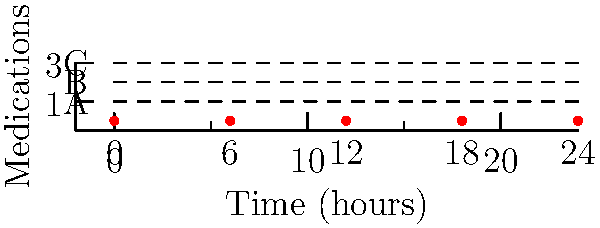As a heart patient, you're prescribed three medications (A, B, and C) to be taken at different times throughout the day. The diagram shows a 24-hour schedule grid. How many unique ways can you arrange these medications if each must be taken exactly once within the given time slots (0, 6, 12, 18, 24 hours), and the order of medications matters? Let's approach this step-by-step:

1) We have 5 time slots (0, 6, 12, 18, 24 hours) and 3 medications (A, B, C).

2) This is a permutation problem because the order matters (taking medication A at 0 hours is different from taking it at 6 hours).

3) We need to choose 3 time slots out of 5 for our 3 medications. This can be done in $P(5,3)$ ways, where $P(n,r)$ represents the number of permutations of $n$ items taken $r$ at a time.

4) $P(5,3) = \frac{5!}{(5-3)!} = \frac{5!}{2!} = 60$

5) For each of these 60 time slot arrangements, we can arrange our 3 medications in $3! = 6$ ways.

6) By the multiplication principle, the total number of unique arrangements is:

   $60 * 6 = 360$

Therefore, there are 360 unique ways to arrange the medications in the given time slots.
Answer: 360 